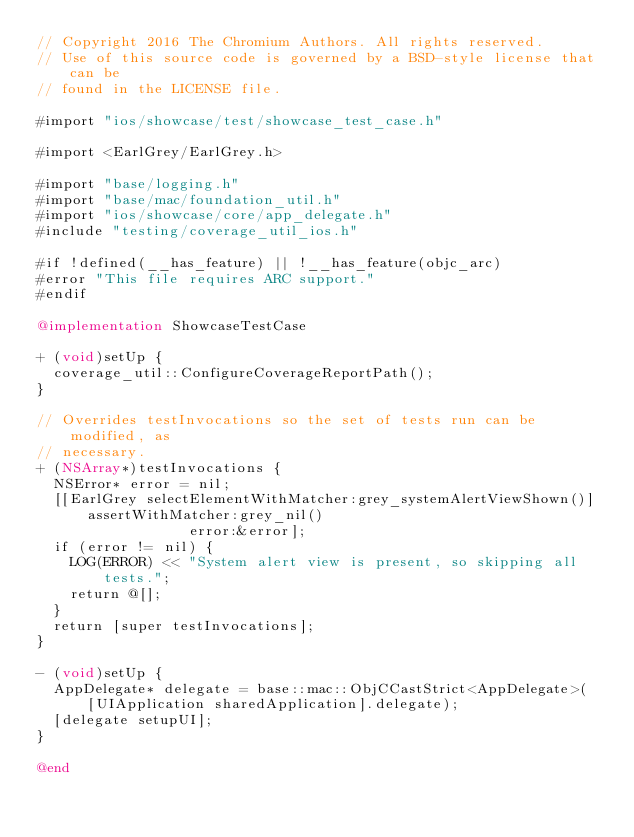<code> <loc_0><loc_0><loc_500><loc_500><_ObjectiveC_>// Copyright 2016 The Chromium Authors. All rights reserved.
// Use of this source code is governed by a BSD-style license that can be
// found in the LICENSE file.

#import "ios/showcase/test/showcase_test_case.h"

#import <EarlGrey/EarlGrey.h>

#import "base/logging.h"
#import "base/mac/foundation_util.h"
#import "ios/showcase/core/app_delegate.h"
#include "testing/coverage_util_ios.h"

#if !defined(__has_feature) || !__has_feature(objc_arc)
#error "This file requires ARC support."
#endif

@implementation ShowcaseTestCase

+ (void)setUp {
  coverage_util::ConfigureCoverageReportPath();
}

// Overrides testInvocations so the set of tests run can be modified, as
// necessary.
+ (NSArray*)testInvocations {
  NSError* error = nil;
  [[EarlGrey selectElementWithMatcher:grey_systemAlertViewShown()]
      assertWithMatcher:grey_nil()
                  error:&error];
  if (error != nil) {
    LOG(ERROR) << "System alert view is present, so skipping all tests.";
    return @[];
  }
  return [super testInvocations];
}

- (void)setUp {
  AppDelegate* delegate = base::mac::ObjCCastStrict<AppDelegate>(
      [UIApplication sharedApplication].delegate);
  [delegate setupUI];
}

@end
</code> 